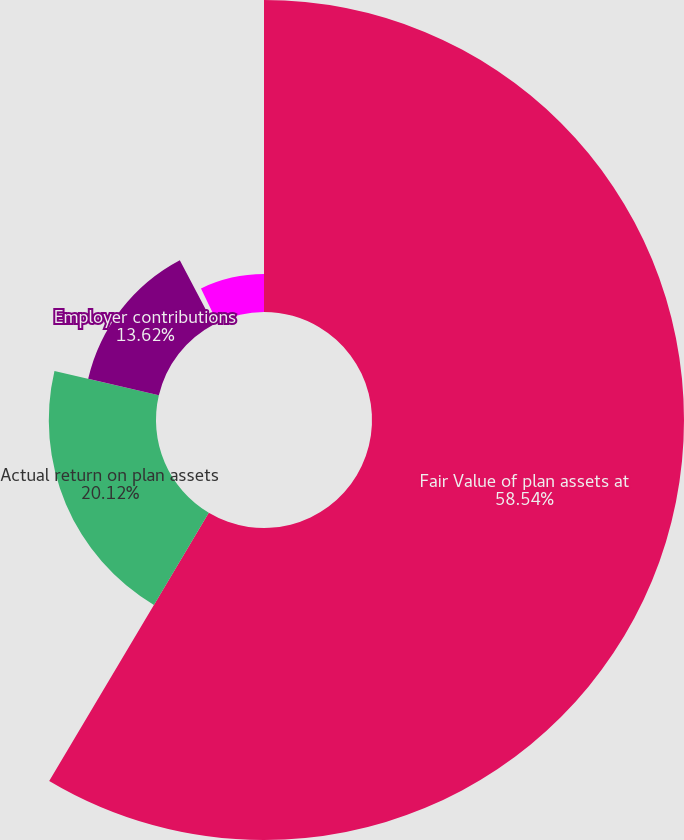Convert chart. <chart><loc_0><loc_0><loc_500><loc_500><pie_chart><fcel>Fair Value of plan assets at<fcel>Actual return on plan assets<fcel>Employer contributions<fcel>Participants' contributions<fcel>Gross benefits paid<nl><fcel>58.55%<fcel>20.12%<fcel>13.62%<fcel>0.61%<fcel>7.11%<nl></chart> 